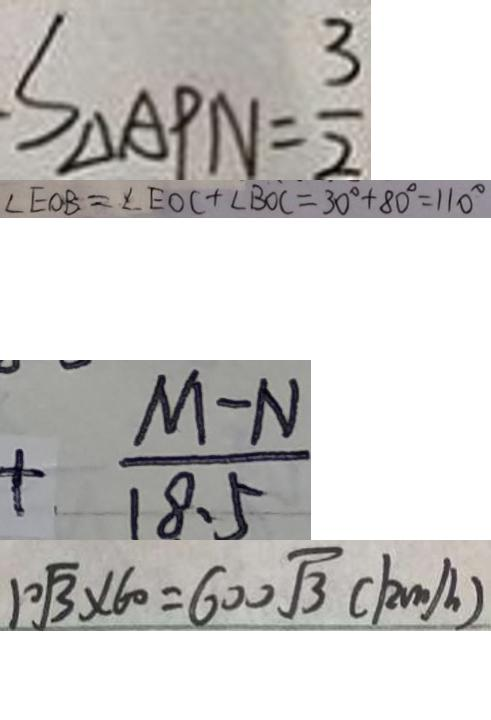<formula> <loc_0><loc_0><loc_500><loc_500>S _ { \Delta A P N } = \frac { 3 } { 2 } 
 \angle E O B = \angle E O C + \angle B O C = 3 0 ^ { \circ } + 8 0 ^ { \circ } = 1 1 0 ^ { \circ } 
 + \frac { M - N } { 1 8 . 5 } 
 1 0 \sqrt { 3 } \times 6 0 = 6 0 0 \sqrt { 3 } ( k m / h )</formula> 